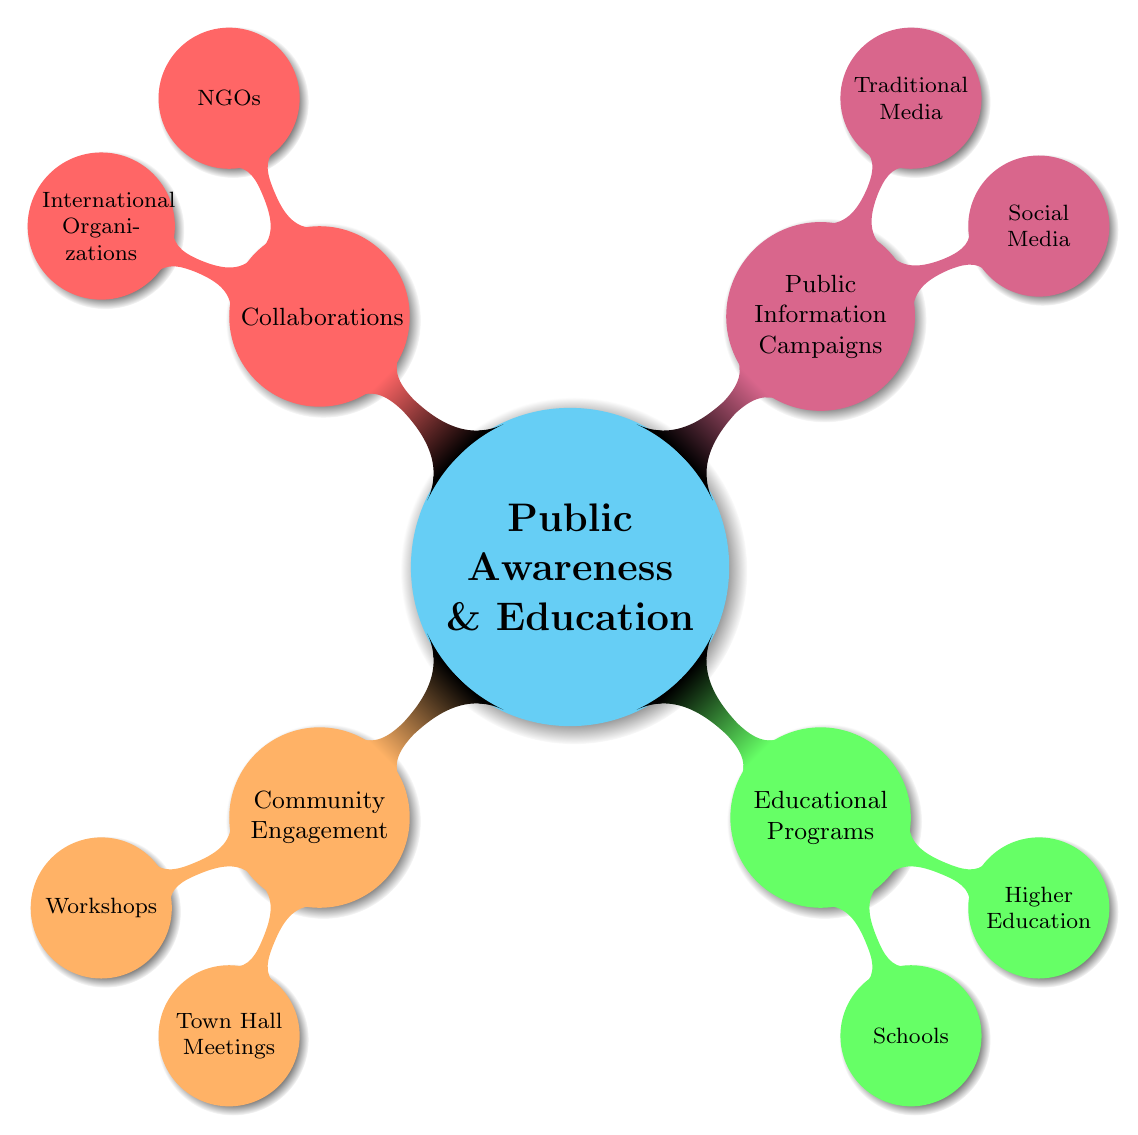What are the four main categories under Public Awareness and Education? The diagram shows four main categories branching from the central concept: Community Engagement, Educational Programs, Public Information Campaigns, and Collaborations.
Answer: Community Engagement, Educational Programs, Public Information Campaigns, Collaborations How many nodes are under the "Community Engagement" category? The "Community Engagement" category has two child nodes: Workshops and Town Hall Meetings. Therefore, the total number of nodes is two.
Answer: 2 What is one topic listed under "Workshops"? Under "Workshops," one of the topics listed is "Climate Change Impact."
Answer: Climate Change Impact What type of media is used for "Awareness Posts"? The type of media used for "Awareness Posts" is Social Media, as it falls under the "Public Information Campaigns" category.
Answer: Social Media Which category includes both Schools and Higher Education? The category that includes both Schools and Higher Education is "Educational Programs."
Answer: Educational Programs What is a key activity mentioned for "Town Hall Meetings"? A key activity mentioned for "Town Hall Meetings" is "Feedback Sessions," which involves gathering community input on mitigation strategies.
Answer: Feedback Sessions Which node under "Collaborations" involves engaging and training volunteers? The node that involves engaging and training volunteers is "Volunteer Training," which falls under the "NGOs" subgroup of "Collaborations."
Answer: Volunteer Training What type of initiatives do NGOs partner on? NGOs partner on "Partnership Programs," which involve joint initiatives with environmental and disaster response NGOs.
Answer: Partnership Programs How do international organizations share resources? International organizations share resources through "Resource Sharing," which provides access to research and best practices.
Answer: Resource Sharing 